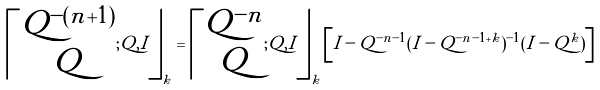<formula> <loc_0><loc_0><loc_500><loc_500>\left \lceil \begin{matrix} Q ^ { - ( n + 1 ) } \\ Q \end{matrix} ; Q , I \right \rfloor _ { k } = \left \lceil \begin{matrix} Q ^ { - n } \\ Q \end{matrix} ; Q , I \right \rfloor _ { k } \left [ I - Q ^ { - n - 1 } ( I - Q ^ { - n - 1 + k } ) ^ { - 1 } ( I - Q ^ { k } ) \right ]</formula> 